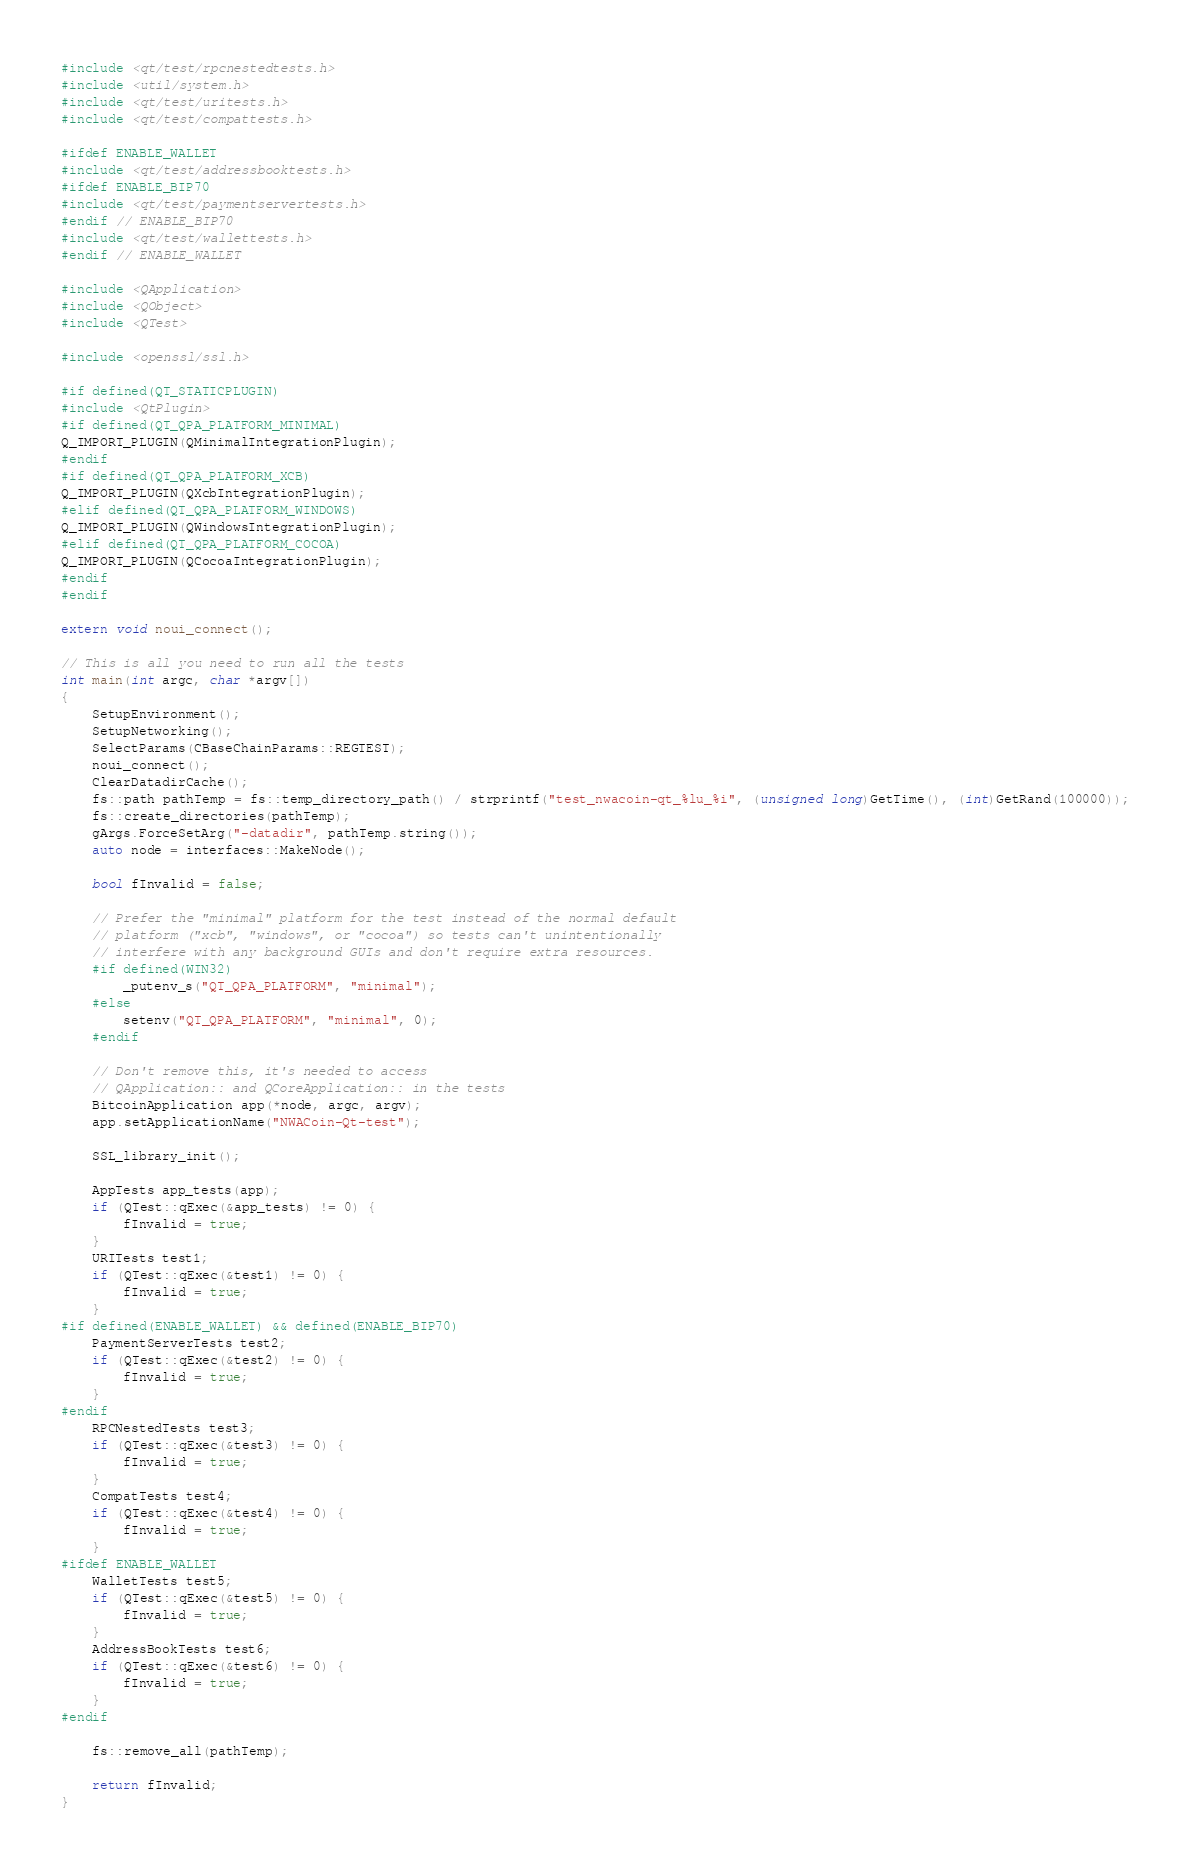<code> <loc_0><loc_0><loc_500><loc_500><_C++_>#include <qt/test/rpcnestedtests.h>
#include <util/system.h>
#include <qt/test/uritests.h>
#include <qt/test/compattests.h>

#ifdef ENABLE_WALLET
#include <qt/test/addressbooktests.h>
#ifdef ENABLE_BIP70
#include <qt/test/paymentservertests.h>
#endif // ENABLE_BIP70
#include <qt/test/wallettests.h>
#endif // ENABLE_WALLET

#include <QApplication>
#include <QObject>
#include <QTest>

#include <openssl/ssl.h>

#if defined(QT_STATICPLUGIN)
#include <QtPlugin>
#if defined(QT_QPA_PLATFORM_MINIMAL)
Q_IMPORT_PLUGIN(QMinimalIntegrationPlugin);
#endif
#if defined(QT_QPA_PLATFORM_XCB)
Q_IMPORT_PLUGIN(QXcbIntegrationPlugin);
#elif defined(QT_QPA_PLATFORM_WINDOWS)
Q_IMPORT_PLUGIN(QWindowsIntegrationPlugin);
#elif defined(QT_QPA_PLATFORM_COCOA)
Q_IMPORT_PLUGIN(QCocoaIntegrationPlugin);
#endif
#endif

extern void noui_connect();

// This is all you need to run all the tests
int main(int argc, char *argv[])
{
    SetupEnvironment();
    SetupNetworking();
    SelectParams(CBaseChainParams::REGTEST);
    noui_connect();
    ClearDatadirCache();
    fs::path pathTemp = fs::temp_directory_path() / strprintf("test_nwacoin-qt_%lu_%i", (unsigned long)GetTime(), (int)GetRand(100000));
    fs::create_directories(pathTemp);
    gArgs.ForceSetArg("-datadir", pathTemp.string());
    auto node = interfaces::MakeNode();

    bool fInvalid = false;

    // Prefer the "minimal" platform for the test instead of the normal default
    // platform ("xcb", "windows", or "cocoa") so tests can't unintentionally
    // interfere with any background GUIs and don't require extra resources.
    #if defined(WIN32)
        _putenv_s("QT_QPA_PLATFORM", "minimal");
    #else
        setenv("QT_QPA_PLATFORM", "minimal", 0);
    #endif

    // Don't remove this, it's needed to access
    // QApplication:: and QCoreApplication:: in the tests
    BitcoinApplication app(*node, argc, argv);
    app.setApplicationName("NWACoin-Qt-test");

    SSL_library_init();

    AppTests app_tests(app);
    if (QTest::qExec(&app_tests) != 0) {
        fInvalid = true;
    }
    URITests test1;
    if (QTest::qExec(&test1) != 0) {
        fInvalid = true;
    }
#if defined(ENABLE_WALLET) && defined(ENABLE_BIP70)
    PaymentServerTests test2;
    if (QTest::qExec(&test2) != 0) {
        fInvalid = true;
    }
#endif
    RPCNestedTests test3;
    if (QTest::qExec(&test3) != 0) {
        fInvalid = true;
    }
    CompatTests test4;
    if (QTest::qExec(&test4) != 0) {
        fInvalid = true;
    }
#ifdef ENABLE_WALLET
    WalletTests test5;
    if (QTest::qExec(&test5) != 0) {
        fInvalid = true;
    }
    AddressBookTests test6;
    if (QTest::qExec(&test6) != 0) {
        fInvalid = true;
    }
#endif

    fs::remove_all(pathTemp);

    return fInvalid;
}
</code> 